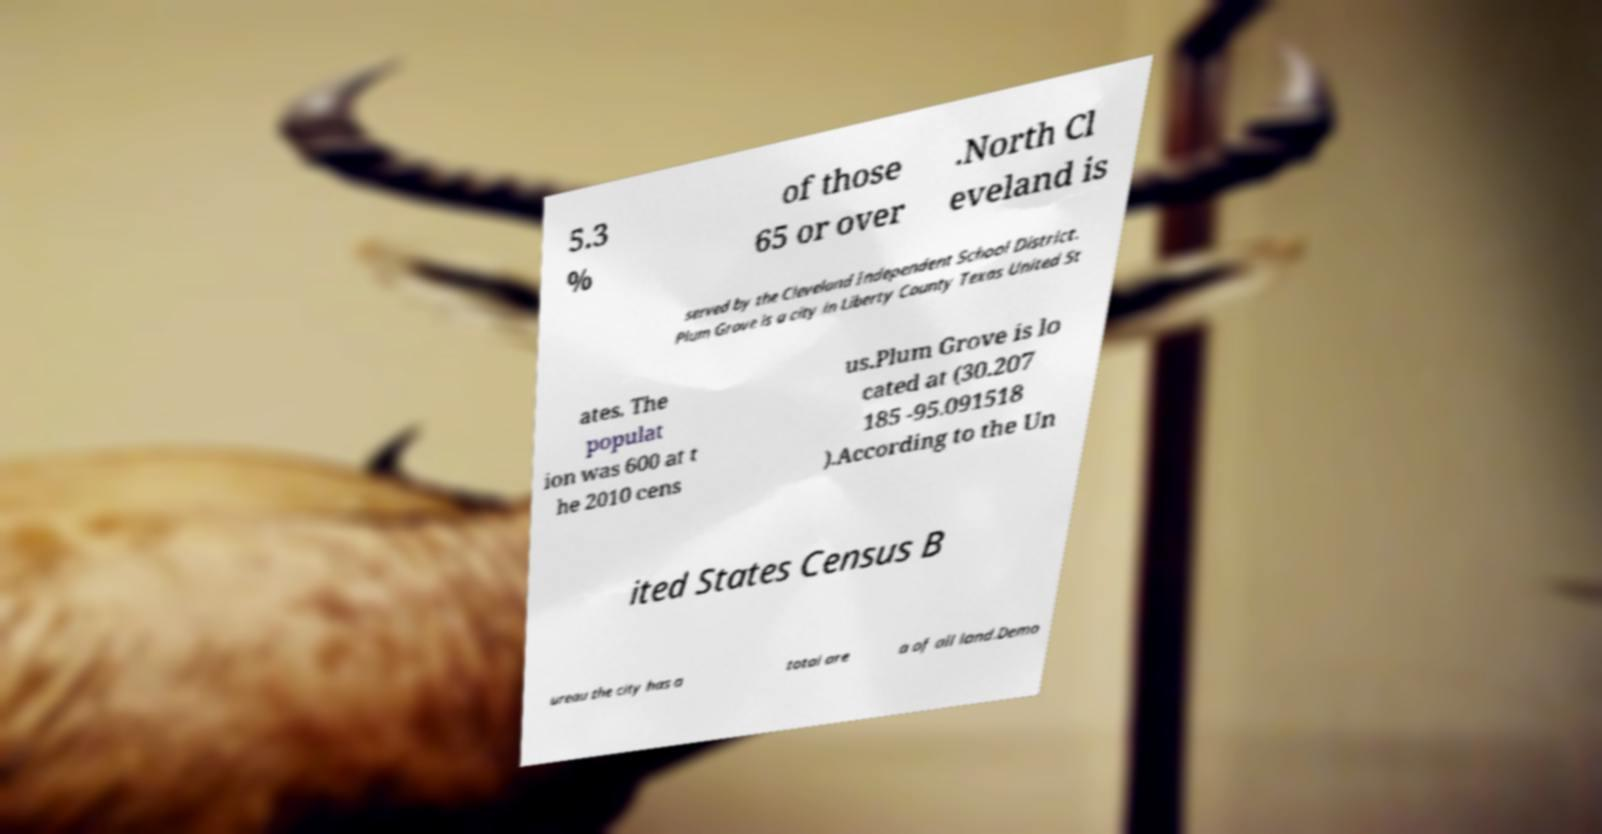Could you extract and type out the text from this image? 5.3 % of those 65 or over .North Cl eveland is served by the Cleveland Independent School District. Plum Grove is a city in Liberty County Texas United St ates. The populat ion was 600 at t he 2010 cens us.Plum Grove is lo cated at (30.207 185 -95.091518 ).According to the Un ited States Census B ureau the city has a total are a of all land.Demo 